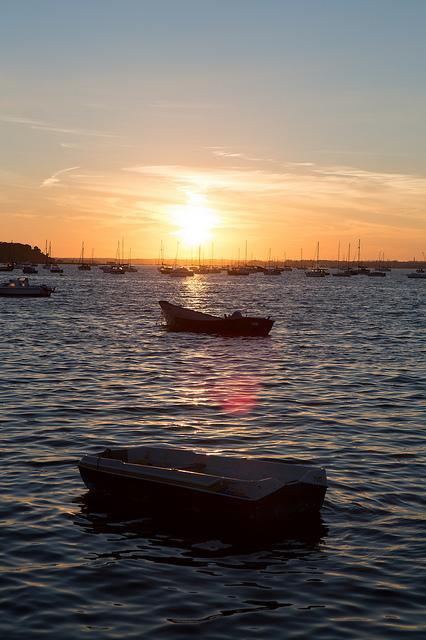How many fishing poles is there?
Give a very brief answer. 0. How many people would be on this boat?
Give a very brief answer. 2. How many people is on the boat?
Give a very brief answer. 0. How many boats are in the picture?
Give a very brief answer. 3. How many people are in red?
Give a very brief answer. 0. 